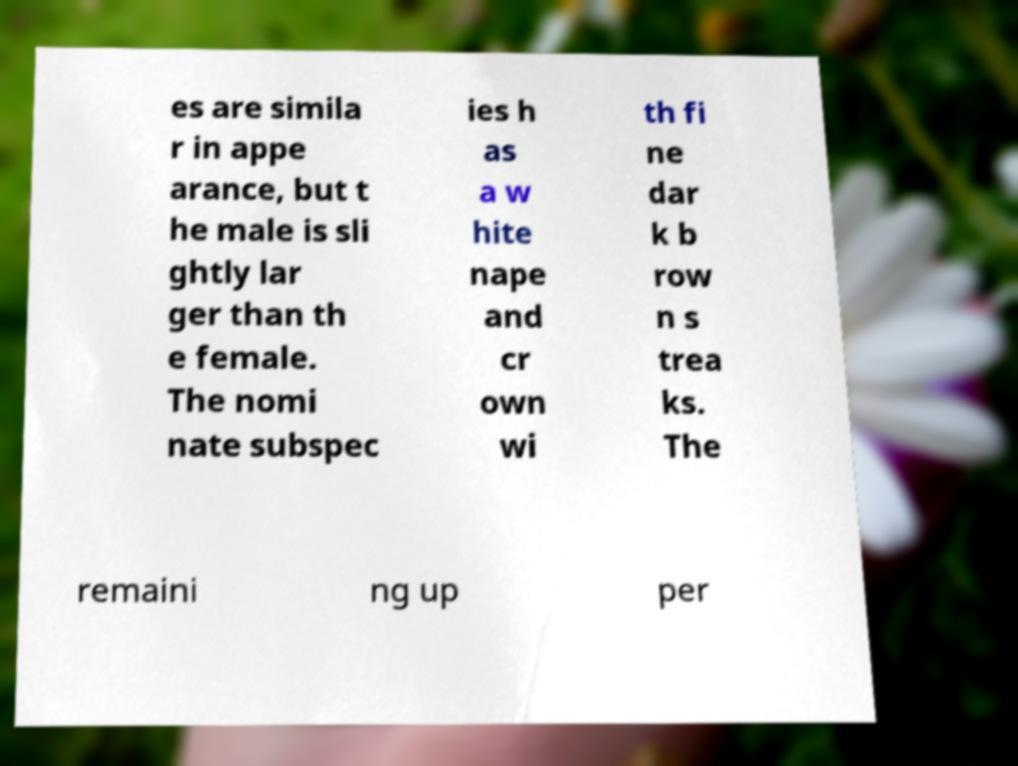For documentation purposes, I need the text within this image transcribed. Could you provide that? es are simila r in appe arance, but t he male is sli ghtly lar ger than th e female. The nomi nate subspec ies h as a w hite nape and cr own wi th fi ne dar k b row n s trea ks. The remaini ng up per 